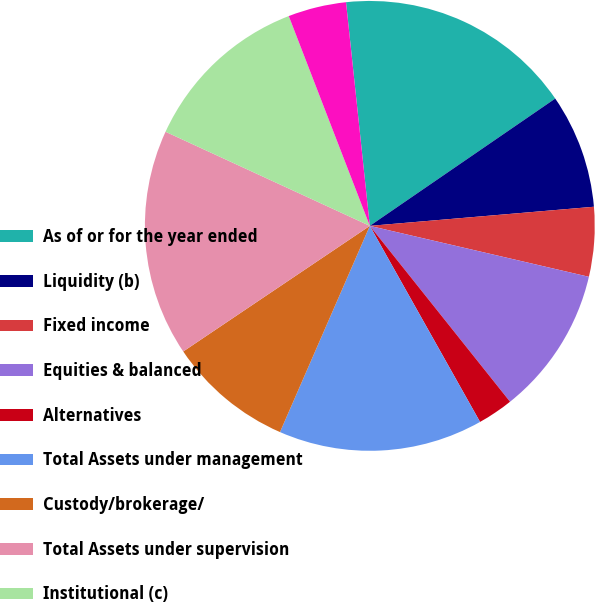<chart> <loc_0><loc_0><loc_500><loc_500><pie_chart><fcel>As of or for the year ended<fcel>Liquidity (b)<fcel>Fixed income<fcel>Equities & balanced<fcel>Alternatives<fcel>Total Assets under management<fcel>Custody/brokerage/<fcel>Total Assets under supervision<fcel>Institutional (c)<fcel>Private Bank<nl><fcel>17.11%<fcel>8.22%<fcel>4.99%<fcel>10.65%<fcel>2.56%<fcel>14.69%<fcel>9.03%<fcel>16.3%<fcel>12.26%<fcel>4.18%<nl></chart> 